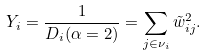Convert formula to latex. <formula><loc_0><loc_0><loc_500><loc_500>Y _ { i } = \frac { 1 } { D _ { i } ( \alpha = 2 ) } = \sum _ { j \in \nu _ { i } } \tilde { w } _ { i j } ^ { 2 } .</formula> 